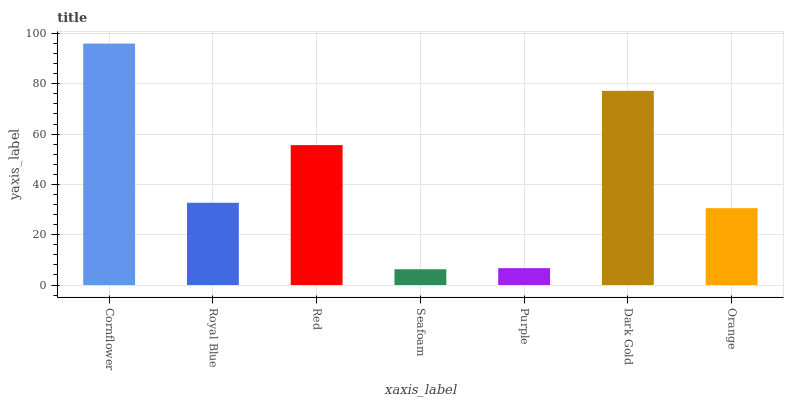Is Seafoam the minimum?
Answer yes or no. Yes. Is Cornflower the maximum?
Answer yes or no. Yes. Is Royal Blue the minimum?
Answer yes or no. No. Is Royal Blue the maximum?
Answer yes or no. No. Is Cornflower greater than Royal Blue?
Answer yes or no. Yes. Is Royal Blue less than Cornflower?
Answer yes or no. Yes. Is Royal Blue greater than Cornflower?
Answer yes or no. No. Is Cornflower less than Royal Blue?
Answer yes or no. No. Is Royal Blue the high median?
Answer yes or no. Yes. Is Royal Blue the low median?
Answer yes or no. Yes. Is Seafoam the high median?
Answer yes or no. No. Is Red the low median?
Answer yes or no. No. 